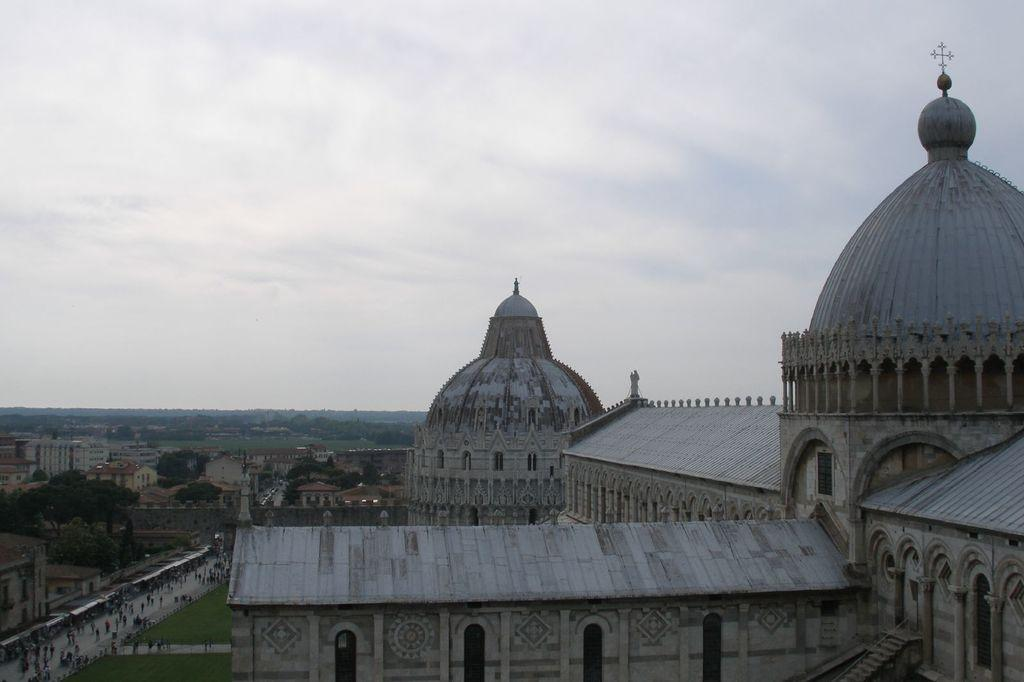What type of structures can be seen in the image? There are buildings in the image. What else can be seen in the image besides buildings? There are trees and people on the road visible in the image. What can be used for illumination in the image? There are lights visible in the image. What is visible at the top of the image? The sky is visible at the top of the image. What type of celery is being used as a traffic control device in the image? There is no celery present in the image, and therefore it cannot be used as a traffic control device. What sound does the alarm make in the image? There is no alarm present in the image, so it is not possible to determine the sound it would make. 